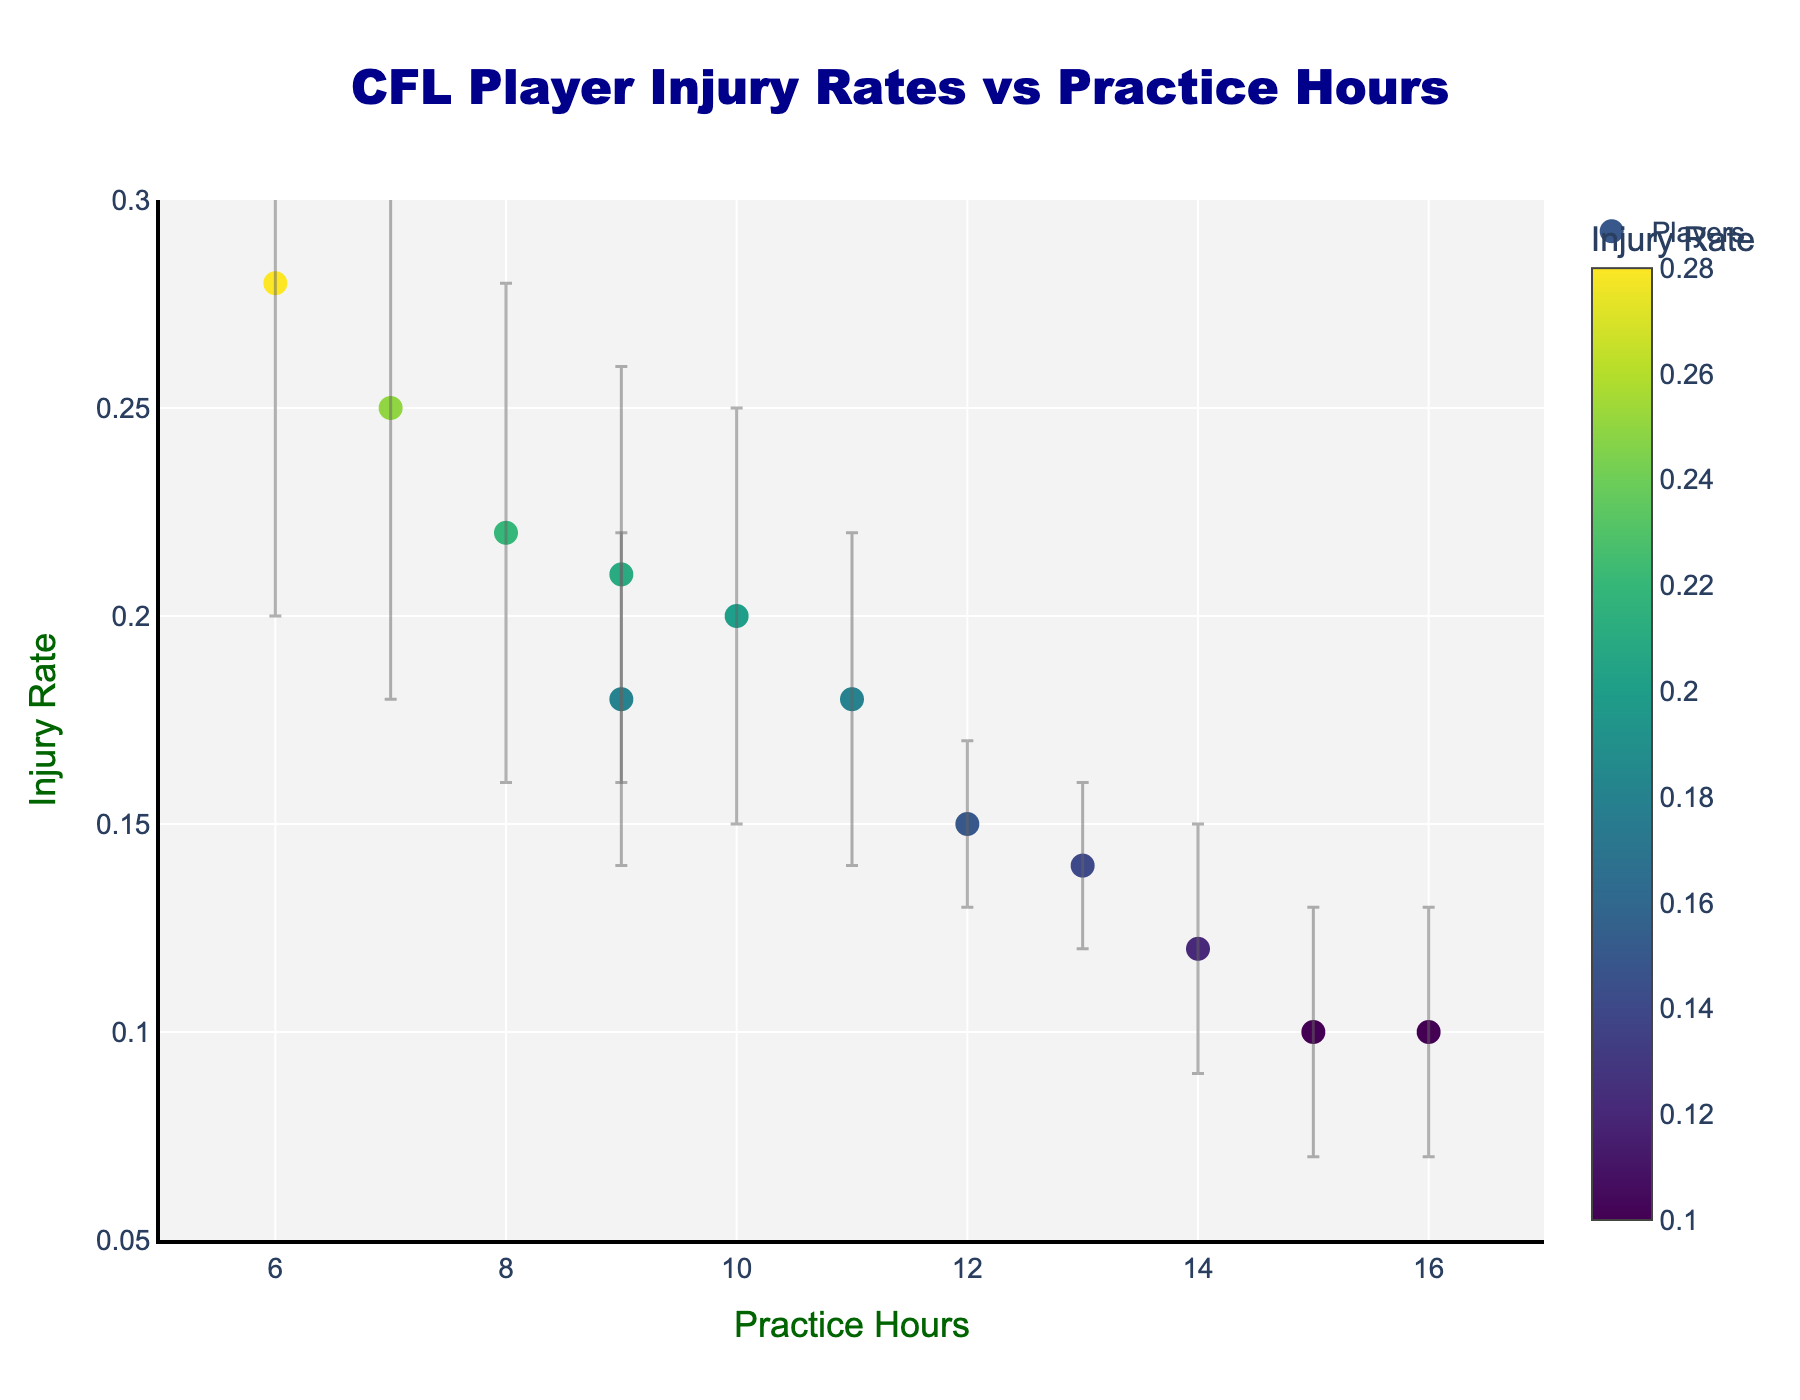What is the title of the figure? The title of the figure is positioned at the top center and is brief, summarizing the x and y axes' relationship.
Answer: CFL Player Injury Rates vs Practice Hours What is the color of the markers? The markers are shaded according to the injury rate using a gradient color scale.
Answer: A shades-of-green color gradient How many players have more than 14 practice hours? Look at the x-axis values to identify the players with practice hours greater than 14. Only two players, Andrew Harris and Mike Edem, are in this range.
Answer: 2 Which player has the highest injury rate? By observing the y-axis values and markers, it shows that William Stanback has the highest injury rate among all the players.
Answer: William Stanback What is the standard deviation range for Darvin Adams? Check the error bars for Darvin Adams (point at Practice Hours 10) to see the extent of the deviation. His standard deviation is ± 0.05, so the range is 0.15 to 0.25.
Answer: 0.15 to 0.25 Is there any relationship between practice hours and injury rates? The scatter plot with error bars helps visualize data points; generally, there’s an inverse correlation as higher practice hours slightly tend to show lower injury rates.
Answer: Inversely related Which player has the smallest standard deviation in their injury rate? Compare the error bar lengths of all players, and Trevor Harris and Brandon Alexander have the shortest error bars due to a deviation of ± 0.02.
Answer: Brandon Alexander and Trevor Harris Who practices the most and what is his injury rate? Find the player at the highest x-axis value (Practice Hours), which is Mike Edem at 16 hours and an injury rate of 0.10.
Answer: Mike Edem, 0.10 What is the average injury rate for players who practice between 8-10 hours? Sum the injury rates of Nic Demski, Michael Reilly, Darvin Adams, and Lucky Whitehead (0.22 + 0.18 + 0.20 + 0.21) and divide by the number of players.
Answer: (0.22 + 0.18 + 0.20 + 0.21) / 4 = 0.2025 How does the injury rate of Bo Levi Mitchell compare to Michael Reilly? By comparing the y-values (injury rates) of Bo Levi Mitchell and Michael Reilly, Bo Levi Mitchell (0.12) has a lower injury rate than Michael Reilly (0.18).
Answer: Bo Levi Mitchell has a lower injury rate 